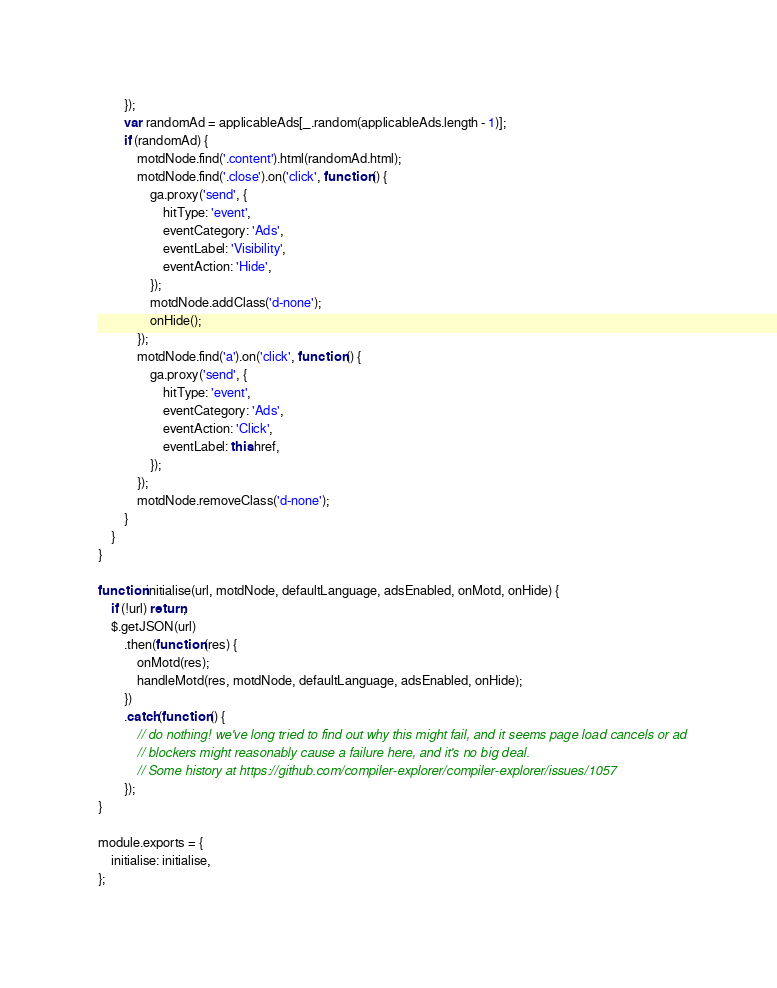Convert code to text. <code><loc_0><loc_0><loc_500><loc_500><_JavaScript_>        });
        var randomAd = applicableAds[_.random(applicableAds.length - 1)];
        if (randomAd) {
            motdNode.find('.content').html(randomAd.html);
            motdNode.find('.close').on('click', function () {
                ga.proxy('send', {
                    hitType: 'event',
                    eventCategory: 'Ads',
                    eventLabel: 'Visibility',
                    eventAction: 'Hide',
                });
                motdNode.addClass('d-none');
                onHide();
            });
            motdNode.find('a').on('click', function () {
                ga.proxy('send', {
                    hitType: 'event',
                    eventCategory: 'Ads',
                    eventAction: 'Click',
                    eventLabel: this.href,
                });
            });
            motdNode.removeClass('d-none');
        }
    }
}

function initialise(url, motdNode, defaultLanguage, adsEnabled, onMotd, onHide) {
    if (!url) return;
    $.getJSON(url)
        .then(function (res) {
            onMotd(res);
            handleMotd(res, motdNode, defaultLanguage, adsEnabled, onHide);
        })
        .catch(function () {
            // do nothing! we've long tried to find out why this might fail, and it seems page load cancels or ad
            // blockers might reasonably cause a failure here, and it's no big deal.
            // Some history at https://github.com/compiler-explorer/compiler-explorer/issues/1057
        });
}

module.exports = {
    initialise: initialise,
};
</code> 